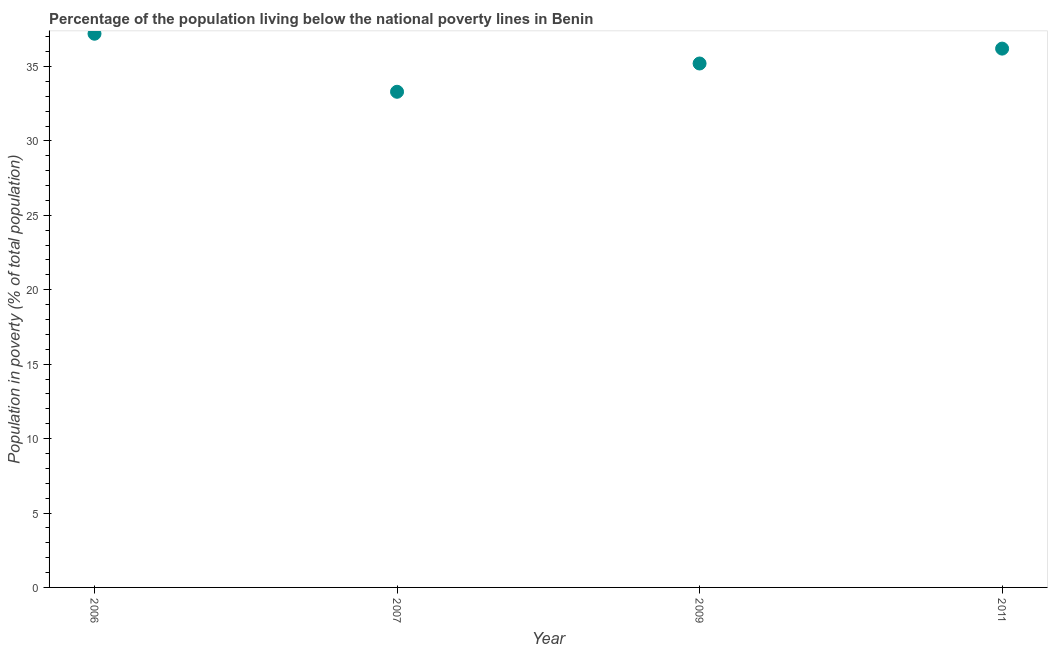What is the percentage of population living below poverty line in 2011?
Provide a short and direct response. 36.2. Across all years, what is the maximum percentage of population living below poverty line?
Your answer should be compact. 37.2. Across all years, what is the minimum percentage of population living below poverty line?
Offer a very short reply. 33.3. In which year was the percentage of population living below poverty line maximum?
Make the answer very short. 2006. What is the sum of the percentage of population living below poverty line?
Provide a short and direct response. 141.9. What is the difference between the percentage of population living below poverty line in 2006 and 2007?
Give a very brief answer. 3.9. What is the average percentage of population living below poverty line per year?
Offer a terse response. 35.48. What is the median percentage of population living below poverty line?
Your response must be concise. 35.7. In how many years, is the percentage of population living below poverty line greater than 24 %?
Your answer should be very brief. 4. What is the ratio of the percentage of population living below poverty line in 2006 to that in 2011?
Give a very brief answer. 1.03. What is the difference between the highest and the second highest percentage of population living below poverty line?
Provide a succinct answer. 1. What is the difference between the highest and the lowest percentage of population living below poverty line?
Your answer should be compact. 3.9. In how many years, is the percentage of population living below poverty line greater than the average percentage of population living below poverty line taken over all years?
Your response must be concise. 2. What is the difference between two consecutive major ticks on the Y-axis?
Provide a succinct answer. 5. What is the title of the graph?
Offer a very short reply. Percentage of the population living below the national poverty lines in Benin. What is the label or title of the Y-axis?
Your response must be concise. Population in poverty (% of total population). What is the Population in poverty (% of total population) in 2006?
Provide a succinct answer. 37.2. What is the Population in poverty (% of total population) in 2007?
Your response must be concise. 33.3. What is the Population in poverty (% of total population) in 2009?
Give a very brief answer. 35.2. What is the Population in poverty (% of total population) in 2011?
Your response must be concise. 36.2. What is the difference between the Population in poverty (% of total population) in 2006 and 2007?
Your answer should be very brief. 3.9. What is the difference between the Population in poverty (% of total population) in 2006 and 2009?
Provide a succinct answer. 2. What is the difference between the Population in poverty (% of total population) in 2006 and 2011?
Provide a short and direct response. 1. What is the ratio of the Population in poverty (% of total population) in 2006 to that in 2007?
Provide a short and direct response. 1.12. What is the ratio of the Population in poverty (% of total population) in 2006 to that in 2009?
Provide a succinct answer. 1.06. What is the ratio of the Population in poverty (% of total population) in 2006 to that in 2011?
Provide a short and direct response. 1.03. What is the ratio of the Population in poverty (% of total population) in 2007 to that in 2009?
Keep it short and to the point. 0.95. What is the ratio of the Population in poverty (% of total population) in 2007 to that in 2011?
Give a very brief answer. 0.92. 